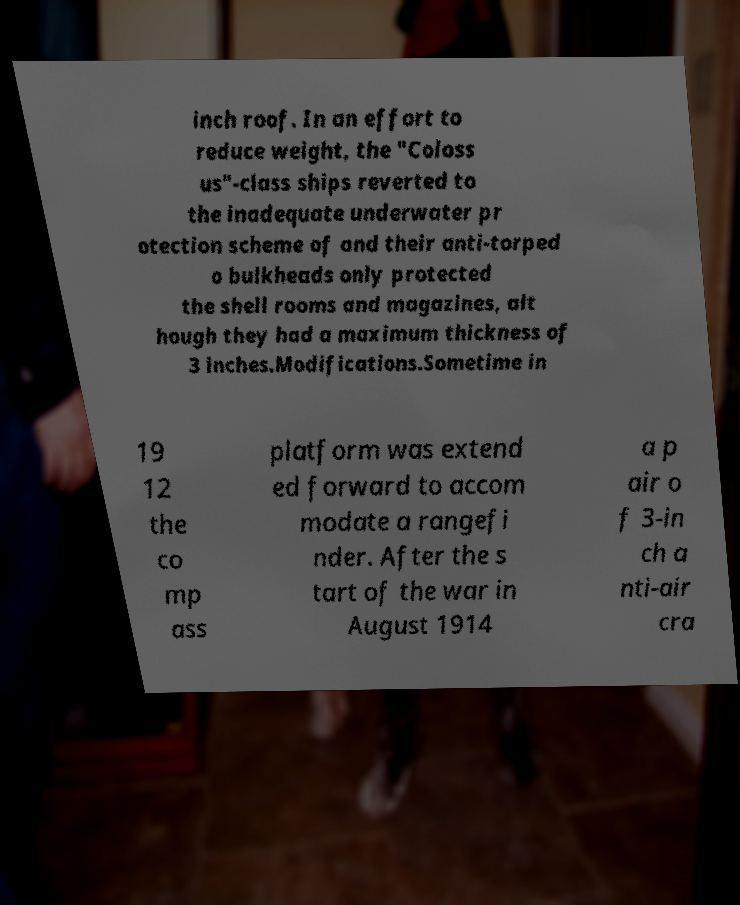Please identify and transcribe the text found in this image. inch roof. In an effort to reduce weight, the "Coloss us"-class ships reverted to the inadequate underwater pr otection scheme of and their anti-torped o bulkheads only protected the shell rooms and magazines, alt hough they had a maximum thickness of 3 inches.Modifications.Sometime in 19 12 the co mp ass platform was extend ed forward to accom modate a rangefi nder. After the s tart of the war in August 1914 a p air o f 3-in ch a nti-air cra 